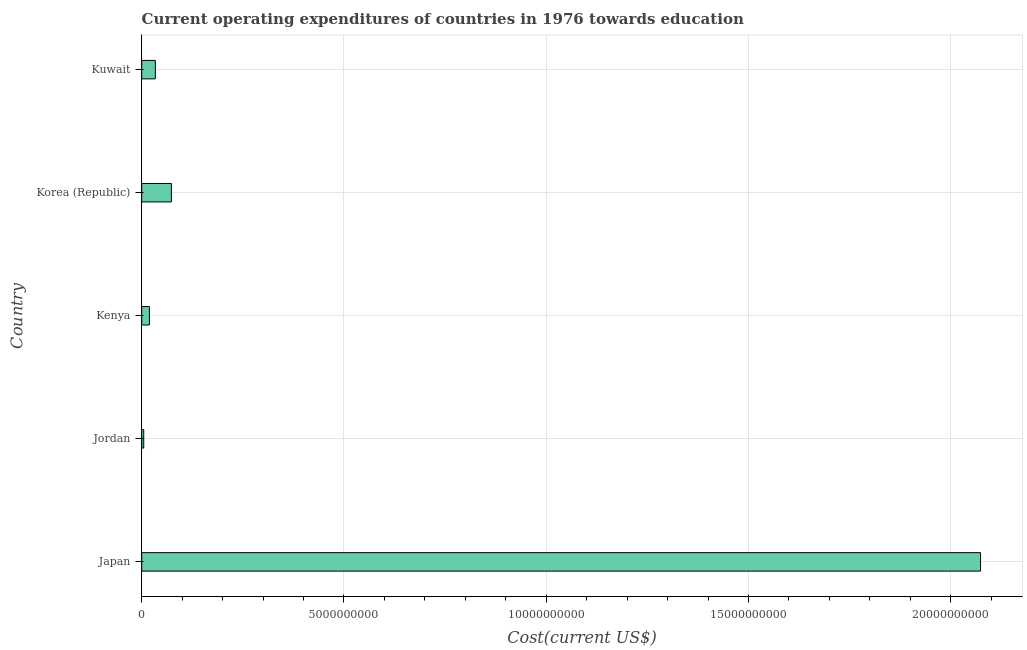Does the graph contain any zero values?
Offer a very short reply. No. What is the title of the graph?
Keep it short and to the point. Current operating expenditures of countries in 1976 towards education. What is the label or title of the X-axis?
Your answer should be compact. Cost(current US$). What is the education expenditure in Korea (Republic)?
Your answer should be very brief. 7.34e+08. Across all countries, what is the maximum education expenditure?
Make the answer very short. 2.07e+1. Across all countries, what is the minimum education expenditure?
Keep it short and to the point. 4.97e+07. In which country was the education expenditure minimum?
Provide a succinct answer. Jordan. What is the sum of the education expenditure?
Provide a succinct answer. 2.20e+1. What is the difference between the education expenditure in Japan and Jordan?
Your answer should be compact. 2.07e+1. What is the average education expenditure per country?
Your answer should be compact. 4.41e+09. What is the median education expenditure?
Provide a succinct answer. 3.37e+08. In how many countries, is the education expenditure greater than 12000000000 US$?
Provide a succinct answer. 1. What is the ratio of the education expenditure in Japan to that in Kenya?
Your answer should be very brief. 109.17. Is the difference between the education expenditure in Kenya and Korea (Republic) greater than the difference between any two countries?
Provide a short and direct response. No. What is the difference between the highest and the second highest education expenditure?
Provide a succinct answer. 2.00e+1. Is the sum of the education expenditure in Japan and Kenya greater than the maximum education expenditure across all countries?
Keep it short and to the point. Yes. What is the difference between the highest and the lowest education expenditure?
Provide a short and direct response. 2.07e+1. In how many countries, is the education expenditure greater than the average education expenditure taken over all countries?
Your response must be concise. 1. How many countries are there in the graph?
Offer a terse response. 5. What is the difference between two consecutive major ticks on the X-axis?
Offer a very short reply. 5.00e+09. Are the values on the major ticks of X-axis written in scientific E-notation?
Offer a terse response. No. What is the Cost(current US$) of Japan?
Make the answer very short. 2.07e+1. What is the Cost(current US$) of Jordan?
Ensure brevity in your answer.  4.97e+07. What is the Cost(current US$) in Kenya?
Offer a very short reply. 1.90e+08. What is the Cost(current US$) in Korea (Republic)?
Offer a terse response. 7.34e+08. What is the Cost(current US$) of Kuwait?
Provide a short and direct response. 3.37e+08. What is the difference between the Cost(current US$) in Japan and Jordan?
Your answer should be very brief. 2.07e+1. What is the difference between the Cost(current US$) in Japan and Kenya?
Ensure brevity in your answer.  2.05e+1. What is the difference between the Cost(current US$) in Japan and Korea (Republic)?
Make the answer very short. 2.00e+1. What is the difference between the Cost(current US$) in Japan and Kuwait?
Provide a short and direct response. 2.04e+1. What is the difference between the Cost(current US$) in Jordan and Kenya?
Provide a succinct answer. -1.40e+08. What is the difference between the Cost(current US$) in Jordan and Korea (Republic)?
Your response must be concise. -6.84e+08. What is the difference between the Cost(current US$) in Jordan and Kuwait?
Offer a terse response. -2.87e+08. What is the difference between the Cost(current US$) in Kenya and Korea (Republic)?
Your answer should be very brief. -5.44e+08. What is the difference between the Cost(current US$) in Kenya and Kuwait?
Offer a very short reply. -1.47e+08. What is the difference between the Cost(current US$) in Korea (Republic) and Kuwait?
Your answer should be very brief. 3.97e+08. What is the ratio of the Cost(current US$) in Japan to that in Jordan?
Offer a very short reply. 416.9. What is the ratio of the Cost(current US$) in Japan to that in Kenya?
Keep it short and to the point. 109.17. What is the ratio of the Cost(current US$) in Japan to that in Korea (Republic)?
Your response must be concise. 28.27. What is the ratio of the Cost(current US$) in Japan to that in Kuwait?
Provide a succinct answer. 61.58. What is the ratio of the Cost(current US$) in Jordan to that in Kenya?
Offer a very short reply. 0.26. What is the ratio of the Cost(current US$) in Jordan to that in Korea (Republic)?
Provide a short and direct response. 0.07. What is the ratio of the Cost(current US$) in Jordan to that in Kuwait?
Offer a terse response. 0.15. What is the ratio of the Cost(current US$) in Kenya to that in Korea (Republic)?
Provide a short and direct response. 0.26. What is the ratio of the Cost(current US$) in Kenya to that in Kuwait?
Offer a very short reply. 0.56. What is the ratio of the Cost(current US$) in Korea (Republic) to that in Kuwait?
Keep it short and to the point. 2.18. 